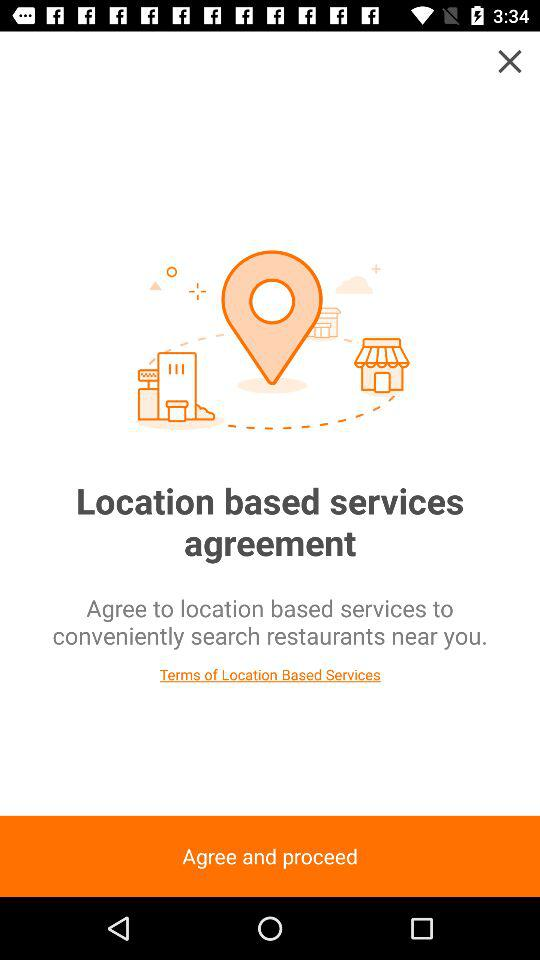What application can be used to log in to the profile? The applications "Facebook" and "Kakao" can be used to log in. 